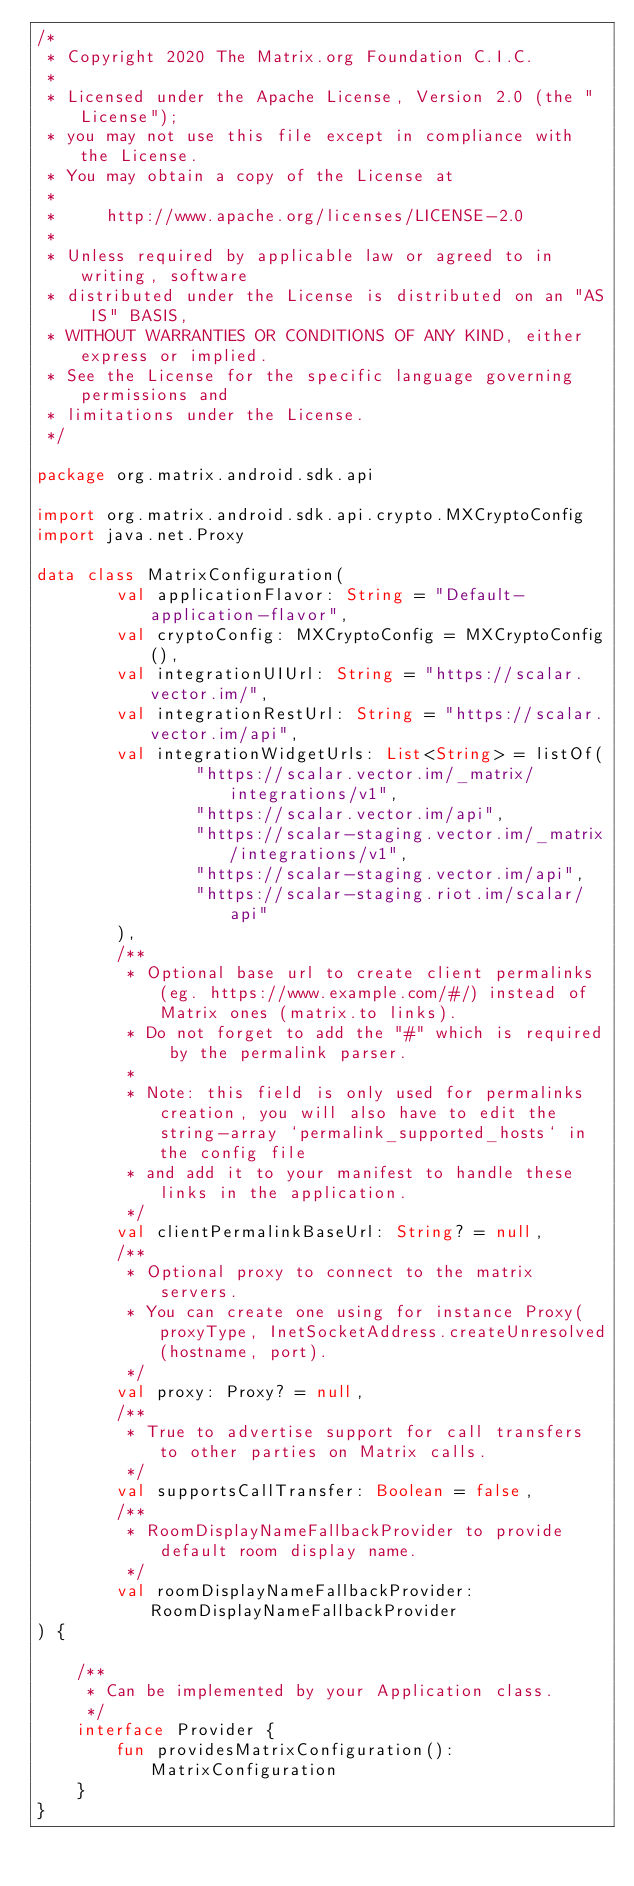Convert code to text. <code><loc_0><loc_0><loc_500><loc_500><_Kotlin_>/*
 * Copyright 2020 The Matrix.org Foundation C.I.C.
 *
 * Licensed under the Apache License, Version 2.0 (the "License");
 * you may not use this file except in compliance with the License.
 * You may obtain a copy of the License at
 *
 *     http://www.apache.org/licenses/LICENSE-2.0
 *
 * Unless required by applicable law or agreed to in writing, software
 * distributed under the License is distributed on an "AS IS" BASIS,
 * WITHOUT WARRANTIES OR CONDITIONS OF ANY KIND, either express or implied.
 * See the License for the specific language governing permissions and
 * limitations under the License.
 */

package org.matrix.android.sdk.api

import org.matrix.android.sdk.api.crypto.MXCryptoConfig
import java.net.Proxy

data class MatrixConfiguration(
        val applicationFlavor: String = "Default-application-flavor",
        val cryptoConfig: MXCryptoConfig = MXCryptoConfig(),
        val integrationUIUrl: String = "https://scalar.vector.im/",
        val integrationRestUrl: String = "https://scalar.vector.im/api",
        val integrationWidgetUrls: List<String> = listOf(
                "https://scalar.vector.im/_matrix/integrations/v1",
                "https://scalar.vector.im/api",
                "https://scalar-staging.vector.im/_matrix/integrations/v1",
                "https://scalar-staging.vector.im/api",
                "https://scalar-staging.riot.im/scalar/api"
        ),
        /**
         * Optional base url to create client permalinks (eg. https://www.example.com/#/) instead of Matrix ones (matrix.to links).
         * Do not forget to add the "#" which is required by the permalink parser.
         *
         * Note: this field is only used for permalinks creation, you will also have to edit the string-array `permalink_supported_hosts` in the config file
         * and add it to your manifest to handle these links in the application.
         */
        val clientPermalinkBaseUrl: String? = null,
        /**
         * Optional proxy to connect to the matrix servers.
         * You can create one using for instance Proxy(proxyType, InetSocketAddress.createUnresolved(hostname, port).
         */
        val proxy: Proxy? = null,
        /**
         * True to advertise support for call transfers to other parties on Matrix calls.
         */
        val supportsCallTransfer: Boolean = false,
        /**
         * RoomDisplayNameFallbackProvider to provide default room display name.
         */
        val roomDisplayNameFallbackProvider: RoomDisplayNameFallbackProvider
) {

    /**
     * Can be implemented by your Application class.
     */
    interface Provider {
        fun providesMatrixConfiguration(): MatrixConfiguration
    }
}
</code> 